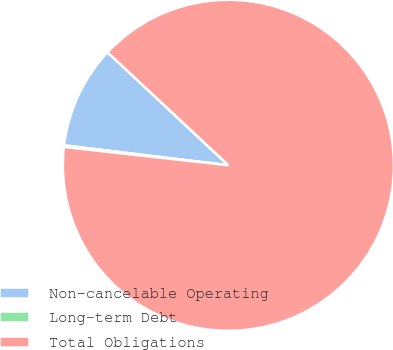Convert chart to OTSL. <chart><loc_0><loc_0><loc_500><loc_500><pie_chart><fcel>Non-cancelable Operating<fcel>Long-term Debt<fcel>Total Obligations<nl><fcel>10.04%<fcel>0.16%<fcel>89.79%<nl></chart> 